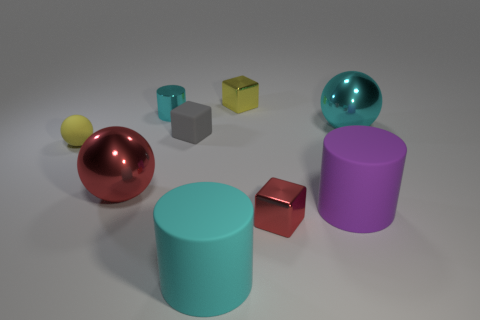There is a purple object; are there any tiny things in front of it?
Ensure brevity in your answer.  Yes. There is another cylinder that is the same color as the small metal cylinder; what is its size?
Provide a succinct answer. Large. Is there a small yellow sphere that has the same material as the large cyan ball?
Provide a succinct answer. No. What is the color of the metallic cylinder?
Ensure brevity in your answer.  Cyan. There is a rubber thing that is behind the tiny rubber sphere; does it have the same shape as the small yellow shiny object?
Provide a short and direct response. Yes. What is the shape of the big thing in front of the red object in front of the purple rubber object on the right side of the large red object?
Provide a short and direct response. Cylinder. What is the large ball right of the tiny shiny cylinder made of?
Offer a very short reply. Metal. What color is the rubber ball that is the same size as the yellow shiny thing?
Offer a very short reply. Yellow. Does the gray cube have the same size as the cyan sphere?
Offer a very short reply. No. Are there more tiny gray things that are behind the gray matte block than small blocks that are left of the yellow rubber thing?
Give a very brief answer. No. 